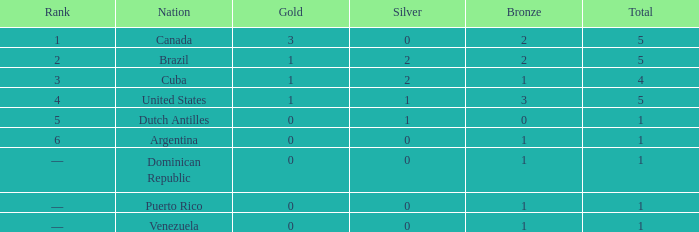What is the average gold total for nations ranked 6 with 1 total medal and 1 bronze medal? None. 